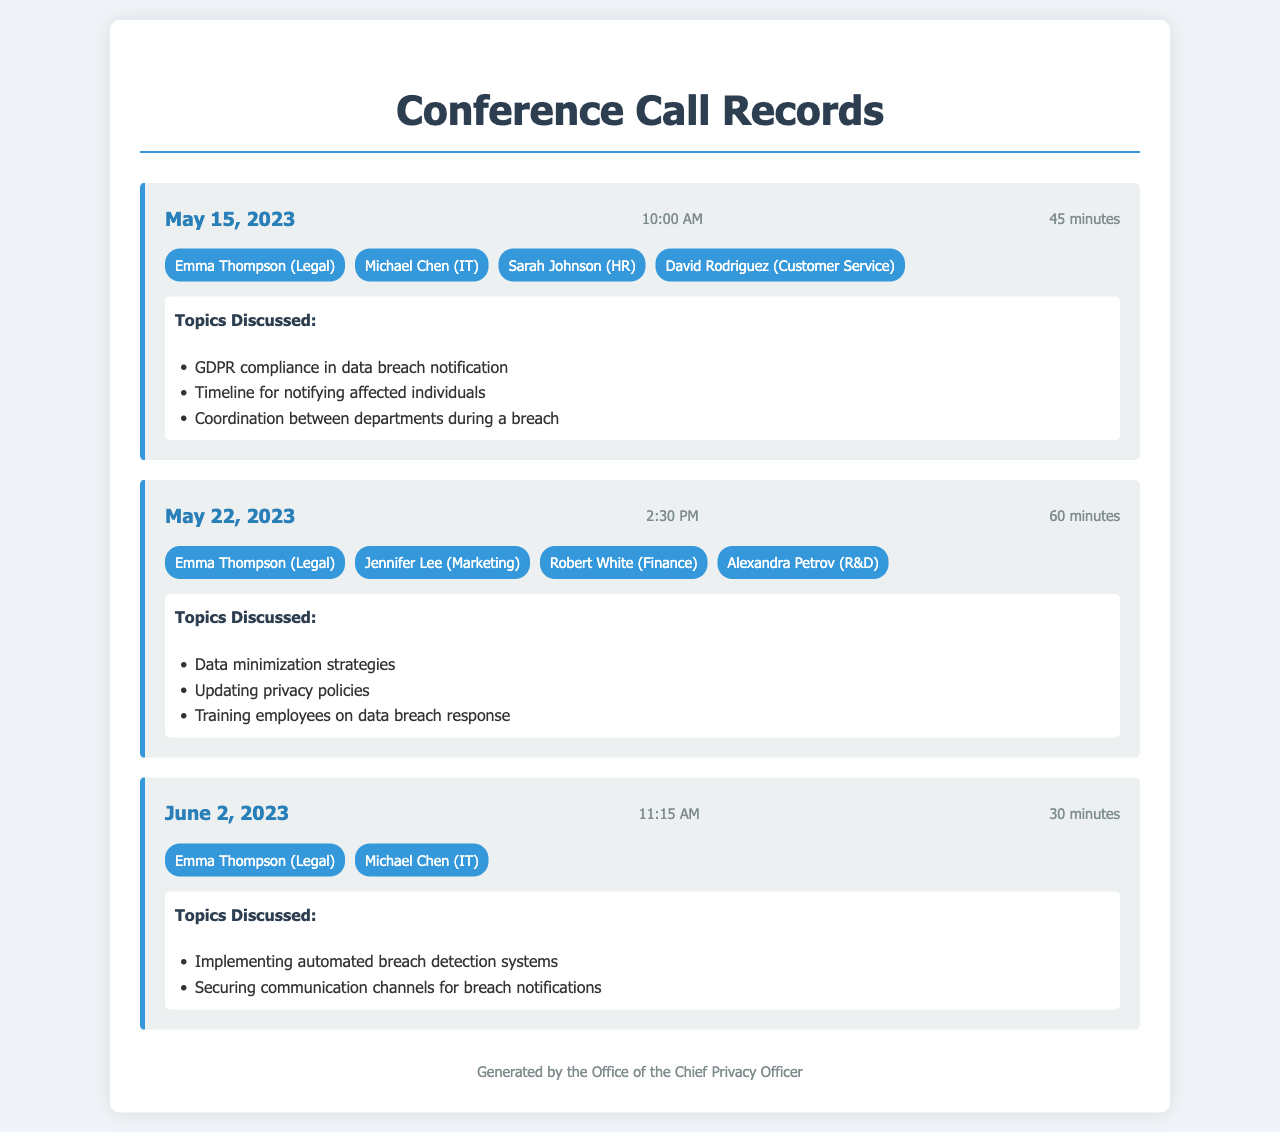What is the date of the first conference call? The date of the first conference call is provided in the document as May 15, 2023.
Answer: May 15, 2023 Who participated in the second conference call? The participants of the second conference call listed in the document include Emma Thompson, Jennifer Lee, Robert White, and Alexandra Petrov.
Answer: Emma Thompson, Jennifer Lee, Robert White, Alexandra Petrov How long was the call on June 2, 2023? The duration of the call on June 2, 2023, is specified in the document as 30 minutes.
Answer: 30 minutes What topic was discussed in the first conference call? The first conference call discussed GDPR compliance in data breach notification, among other topics mentioned.
Answer: GDPR compliance in data breach notification Which department was represented by Michael Chen? Michael Chen is identified in the document as the participant from the IT department.
Answer: IT How many participants were in the call on May 22, 2023? The number of participants in the call on May 22, 2023, can be counted from the document and is noted to be four.
Answer: Four What is the main purpose of these conference calls? The conference calls were focused on data breach notification procedures in relation to GDPR compliance.
Answer: GDPR compliance What was the call length for the second conference call? The call length for the second conference call is mentioned in the document as 60 minutes.
Answer: 60 minutes 